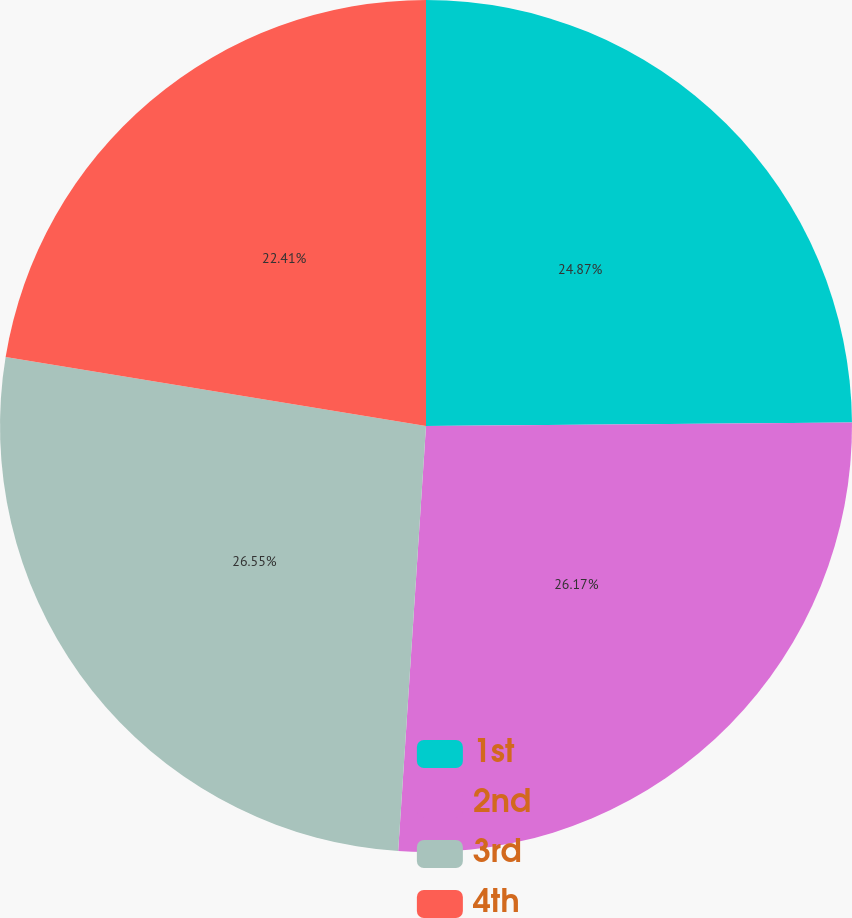Convert chart to OTSL. <chart><loc_0><loc_0><loc_500><loc_500><pie_chart><fcel>1st<fcel>2nd<fcel>3rd<fcel>4th<nl><fcel>24.87%<fcel>26.17%<fcel>26.55%<fcel>22.41%<nl></chart> 